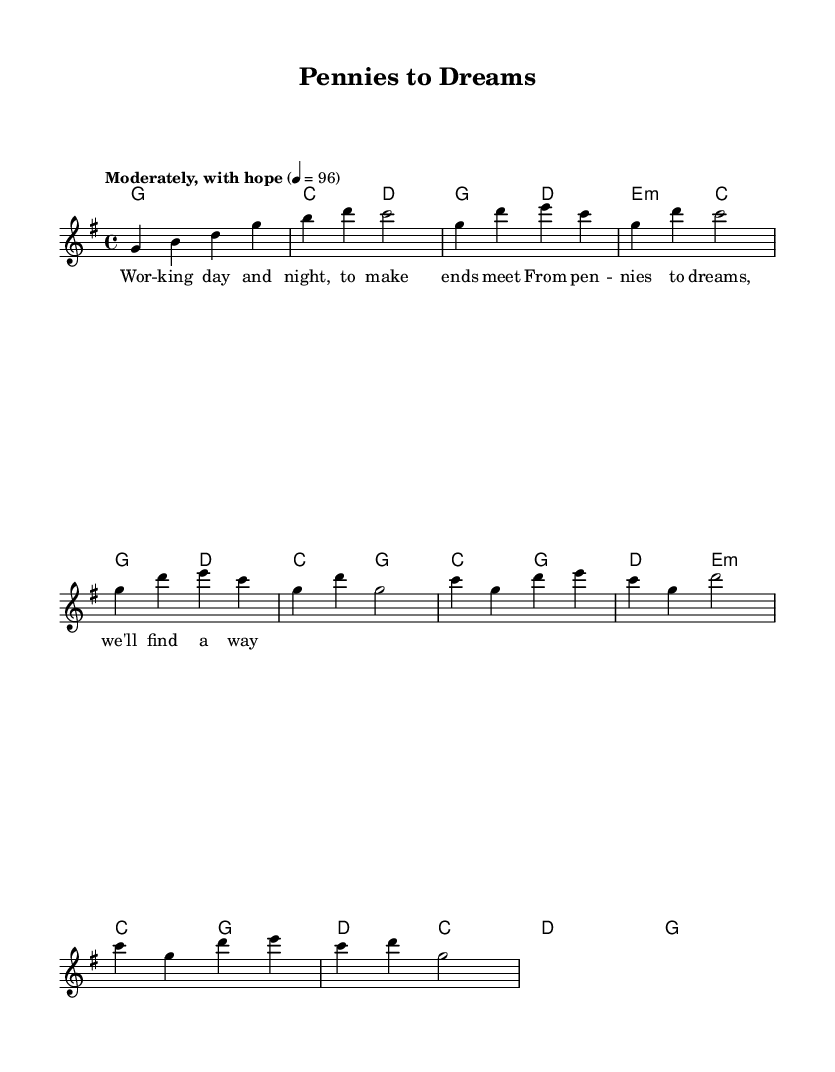What is the key signature of this music? The key signature is G major, which has one sharp (F#).
Answer: G major What is the time signature of this music? The time signature is 4/4, which means there are four beats per measure.
Answer: 4/4 What tempo marking is indicated for this piece? The tempo marking is "Moderately, with hope," which suggests a moderate pace.
Answer: Moderately, with hope How many measures are in the chorus section? The chorus section consists of four measures, as indicated in the sheet music layout.
Answer: Four measures What are the main chords used in the verse section? The main chords used in the verse section are G, D, E minor, and C.
Answer: G, D, E minor, C Why is this piece considered uplifting in nature? The uplifting nature comes from its major key, moderato tempo, and hopeful lyrics, which convey a positive message about overcoming struggles.
Answer: Major key and hopeful lyrics 